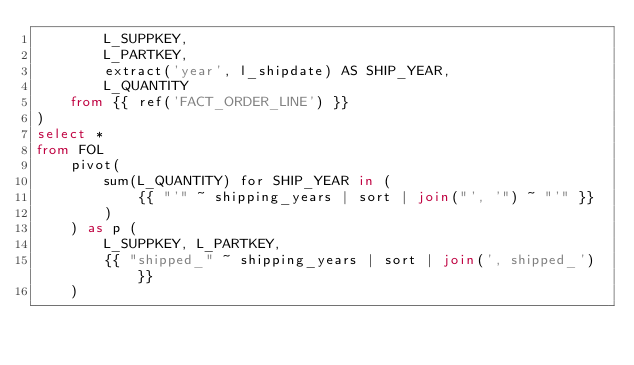Convert code to text. <code><loc_0><loc_0><loc_500><loc_500><_SQL_>        L_SUPPKEY,
        L_PARTKEY,
        extract('year', l_shipdate) AS SHIP_YEAR,
        L_QUANTITY
    from {{ ref('FACT_ORDER_LINE') }}
)
select *
from FOL
    pivot(
        sum(L_QUANTITY) for SHIP_YEAR in (
            {{ "'" ~ shipping_years | sort | join("', '") ~ "'" }}
        )
    ) as p (
        L_SUPPKEY, L_PARTKEY,
        {{ "shipped_" ~ shipping_years | sort | join(', shipped_') }}
    )
</code> 